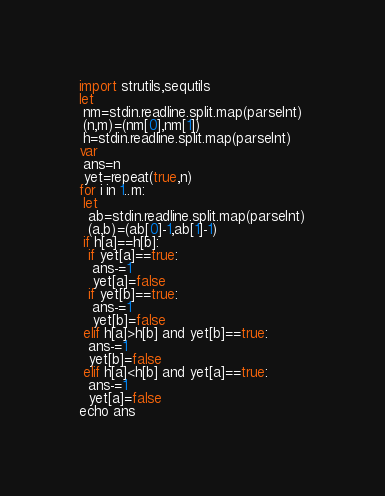Convert code to text. <code><loc_0><loc_0><loc_500><loc_500><_Nim_>import strutils,sequtils
let
 nm=stdin.readline.split.map(parseInt)
 (n,m)=(nm[0],nm[1])
 h=stdin.readline.split.map(parseInt)
var
 ans=n
 yet=repeat(true,n)
for i in 1..m:
 let
  ab=stdin.readline.split.map(parseInt)
  (a,b)=(ab[0]-1,ab[1]-1)
 if h[a]==h[b]:
  if yet[a]==true:
   ans-=1
   yet[a]=false
  if yet[b]==true:
   ans-=1
   yet[b]=false
 elif h[a]>h[b] and yet[b]==true:
  ans-=1
  yet[b]=false
 elif h[a]<h[b] and yet[a]==true:
  ans-=1
  yet[a]=false
echo ans</code> 